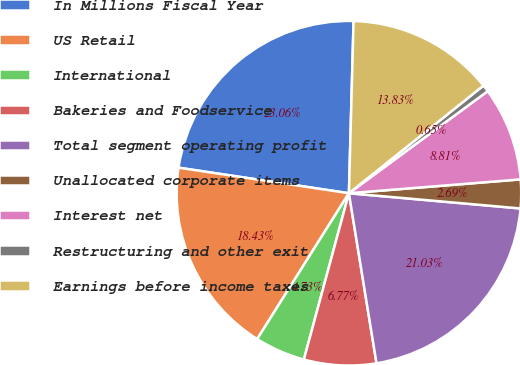<chart> <loc_0><loc_0><loc_500><loc_500><pie_chart><fcel>In Millions Fiscal Year<fcel>US Retail<fcel>International<fcel>Bakeries and Foodservice<fcel>Total segment operating profit<fcel>Unallocated corporate items<fcel>Interest net<fcel>Restructuring and other exit<fcel>Earnings before income taxes<nl><fcel>23.06%<fcel>18.43%<fcel>4.73%<fcel>6.77%<fcel>21.03%<fcel>2.69%<fcel>8.81%<fcel>0.65%<fcel>13.83%<nl></chart> 